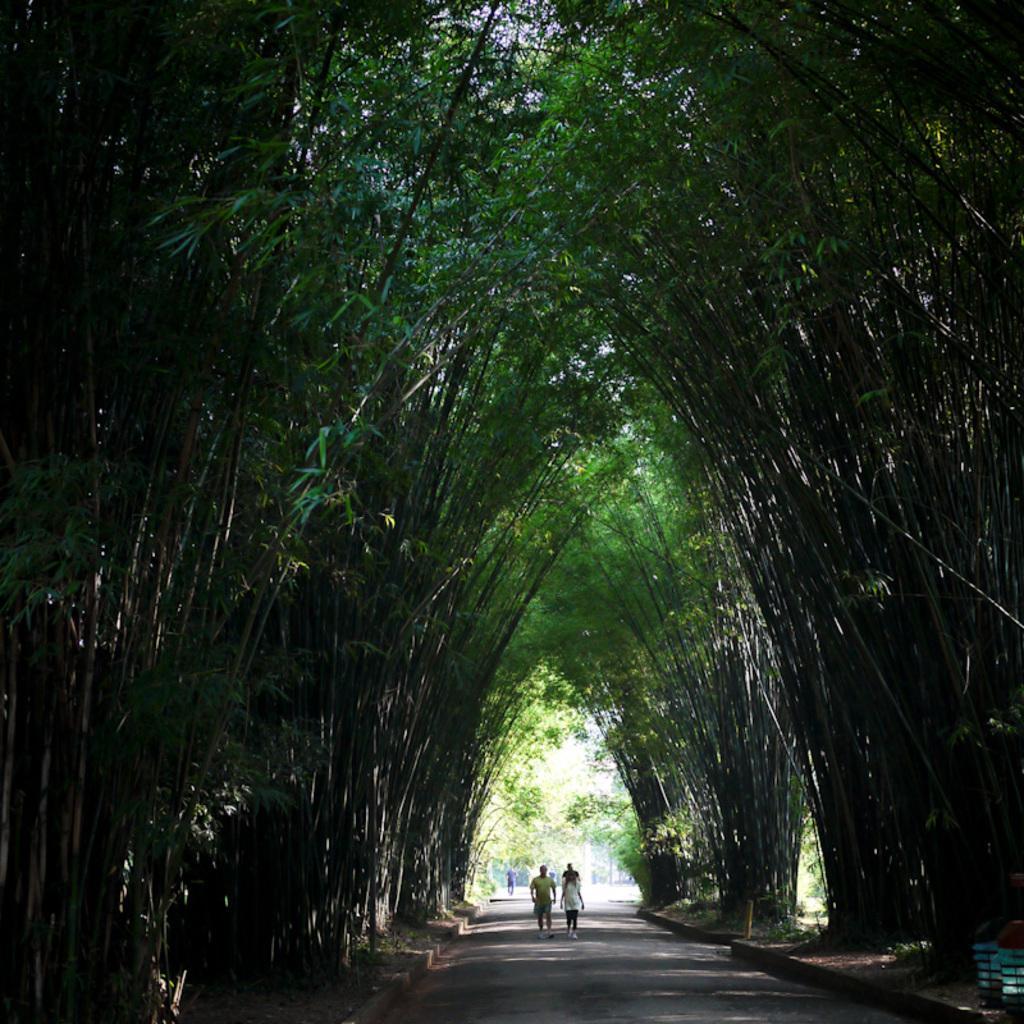Please provide a concise description of this image. This picture is clicked outside. In the center we can see the group of people and we can see the trees and some other items. 